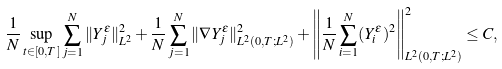Convert formula to latex. <formula><loc_0><loc_0><loc_500><loc_500>& \frac { 1 } { N } \sup _ { t \in [ 0 , T ] } \sum _ { j = 1 } ^ { N } \| Y _ { j } ^ { \varepsilon } \| _ { L ^ { 2 } } ^ { 2 } + \frac { 1 } { N } \sum _ { j = 1 } ^ { N } \| \nabla Y _ { j } ^ { \varepsilon } \| _ { L ^ { 2 } ( 0 , T ; L ^ { 2 } ) } ^ { 2 } + \left \| \frac { 1 } { N } \sum _ { i = 1 } ^ { N } ( Y _ { i } ^ { \varepsilon } ) ^ { 2 } \right \| _ { L ^ { 2 } ( 0 , T ; L ^ { 2 } ) } ^ { 2 } \leq C ,</formula> 